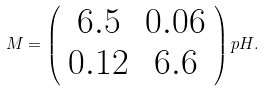<formula> <loc_0><loc_0><loc_500><loc_500>M = \left ( \begin{array} { c c } 6 . 5 & 0 . 0 6 \\ 0 . 1 2 & 6 . 6 \\ \end{array} \right ) p H .</formula> 